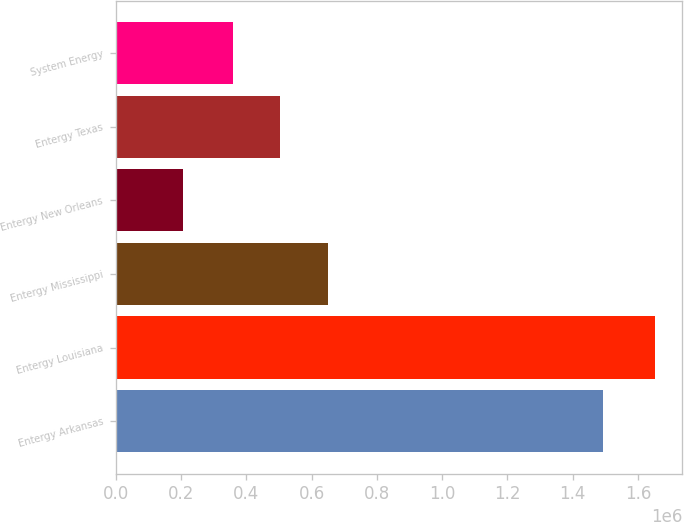Convert chart. <chart><loc_0><loc_0><loc_500><loc_500><bar_chart><fcel>Entergy Arkansas<fcel>Entergy Louisiana<fcel>Entergy Mississippi<fcel>Entergy New Orleans<fcel>Entergy Texas<fcel>System Energy<nl><fcel>1.49288e+06<fcel>1.65294e+06<fcel>648783<fcel>205316<fcel>504020<fcel>359258<nl></chart> 